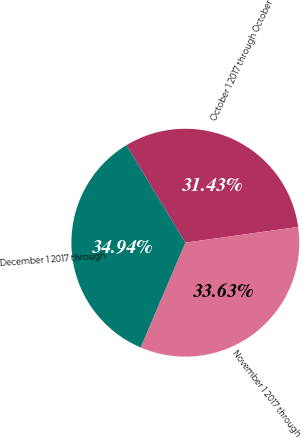Convert chart. <chart><loc_0><loc_0><loc_500><loc_500><pie_chart><fcel>October 1 2017 through October<fcel>November 1 2017 through<fcel>December 1 2017 through<nl><fcel>31.43%<fcel>33.63%<fcel>34.94%<nl></chart> 